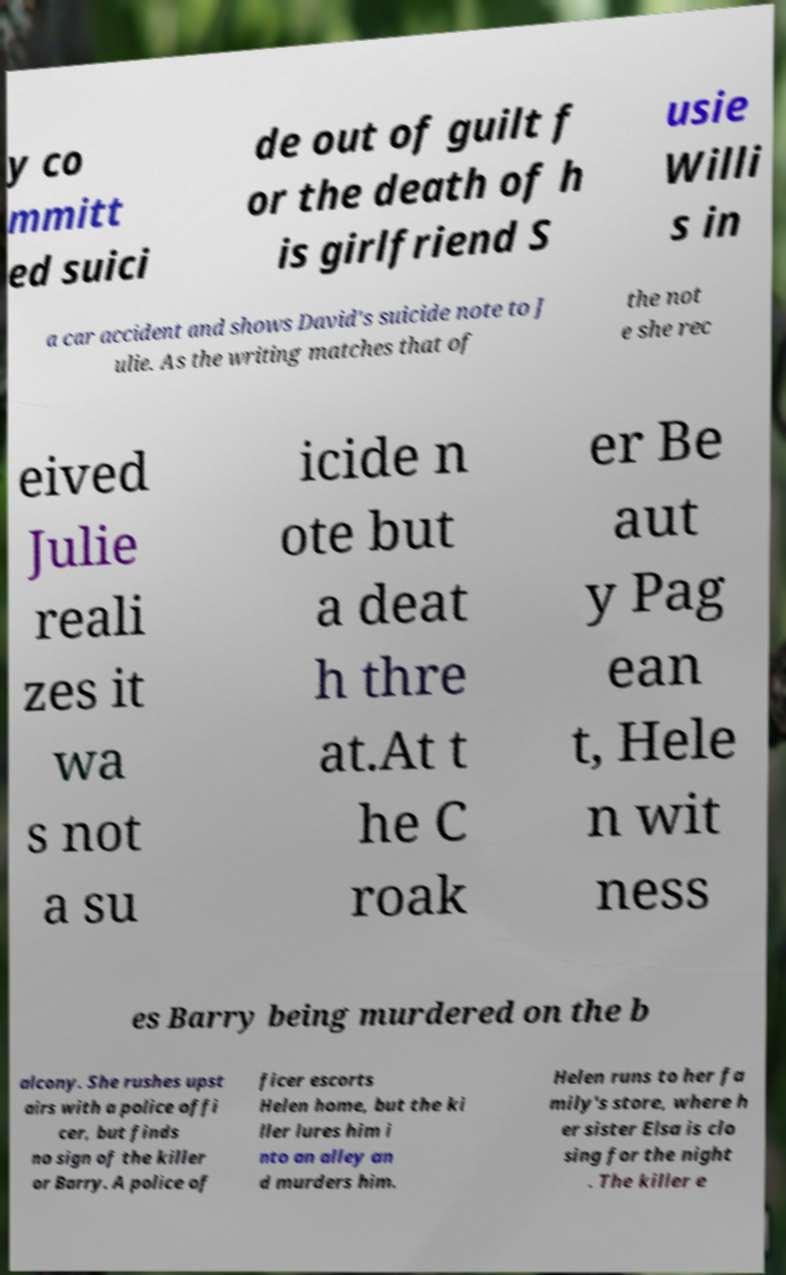Can you accurately transcribe the text from the provided image for me? y co mmitt ed suici de out of guilt f or the death of h is girlfriend S usie Willi s in a car accident and shows David's suicide note to J ulie. As the writing matches that of the not e she rec eived Julie reali zes it wa s not a su icide n ote but a deat h thre at.At t he C roak er Be aut y Pag ean t, Hele n wit ness es Barry being murdered on the b alcony. She rushes upst airs with a police offi cer, but finds no sign of the killer or Barry. A police of ficer escorts Helen home, but the ki ller lures him i nto an alley an d murders him. Helen runs to her fa mily's store, where h er sister Elsa is clo sing for the night . The killer e 